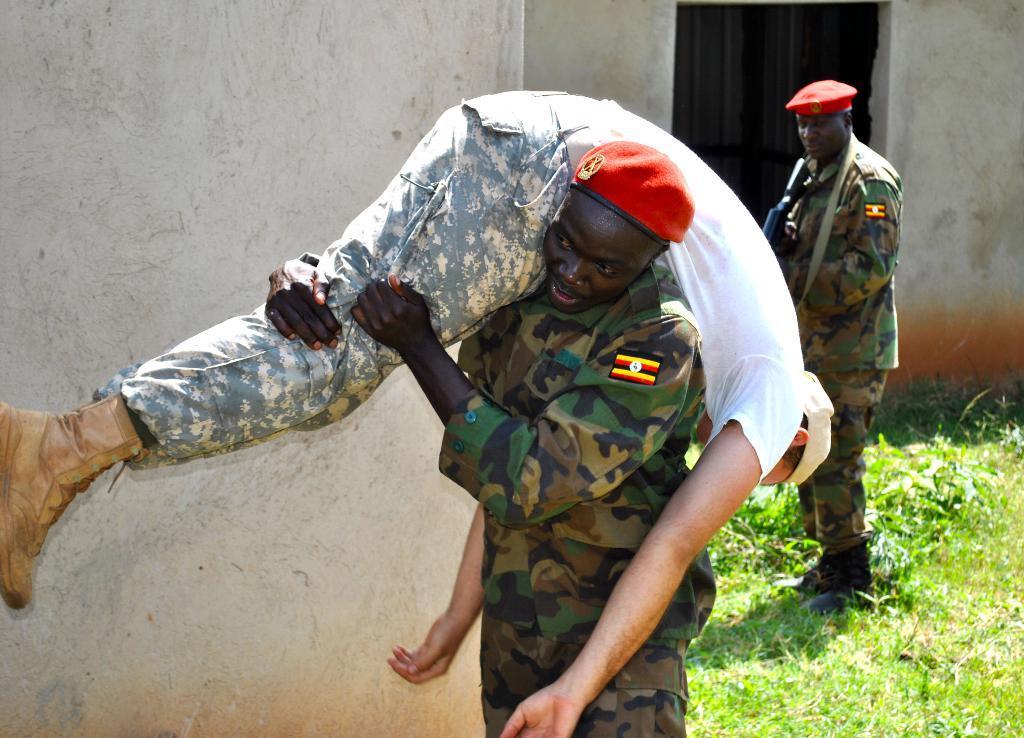In one or two sentences, can you explain what this image depicts? In this picture there is a person standing and holding the other person. At the back there is a person standing and holding the gun and there is a building. At the bottom there are plants and there is grass. 